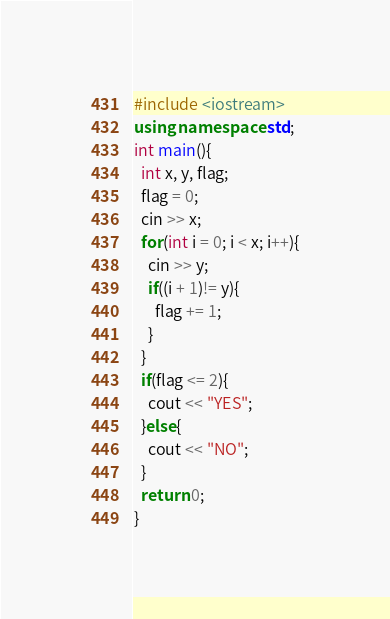<code> <loc_0><loc_0><loc_500><loc_500><_C++_>#include <iostream>
using namespace std;
int main(){
  int x, y, flag;
  flag = 0;
  cin >> x;
  for(int i = 0; i < x; i++){
    cin >> y;
    if((i + 1)!= y){
      flag += 1;
    }
  }
  if(flag <= 2){
    cout << "YES";
  }else{
    cout << "NO";
  }
  return 0;
}</code> 